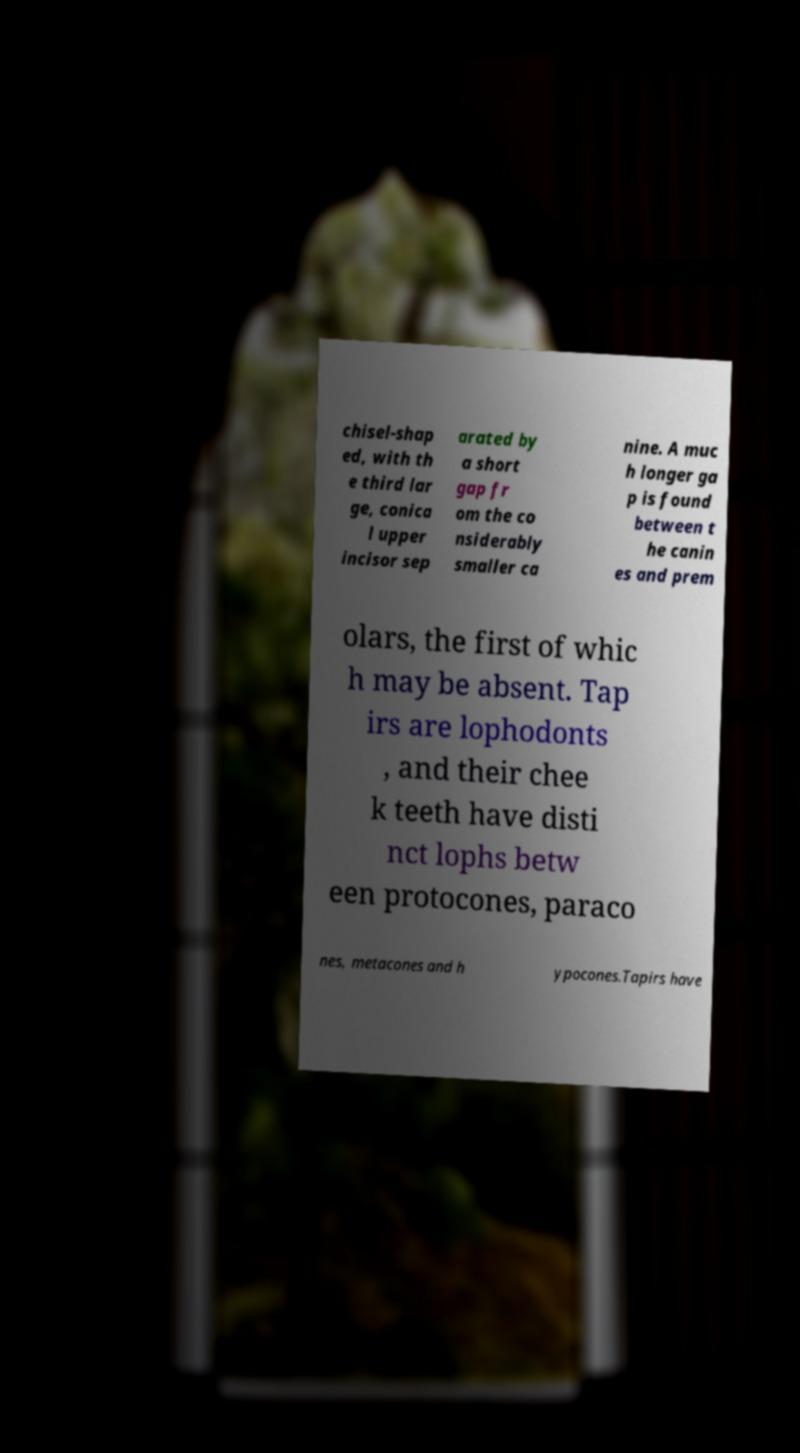Could you extract and type out the text from this image? chisel-shap ed, with th e third lar ge, conica l upper incisor sep arated by a short gap fr om the co nsiderably smaller ca nine. A muc h longer ga p is found between t he canin es and prem olars, the first of whic h may be absent. Tap irs are lophodonts , and their chee k teeth have disti nct lophs betw een protocones, paraco nes, metacones and h ypocones.Tapirs have 